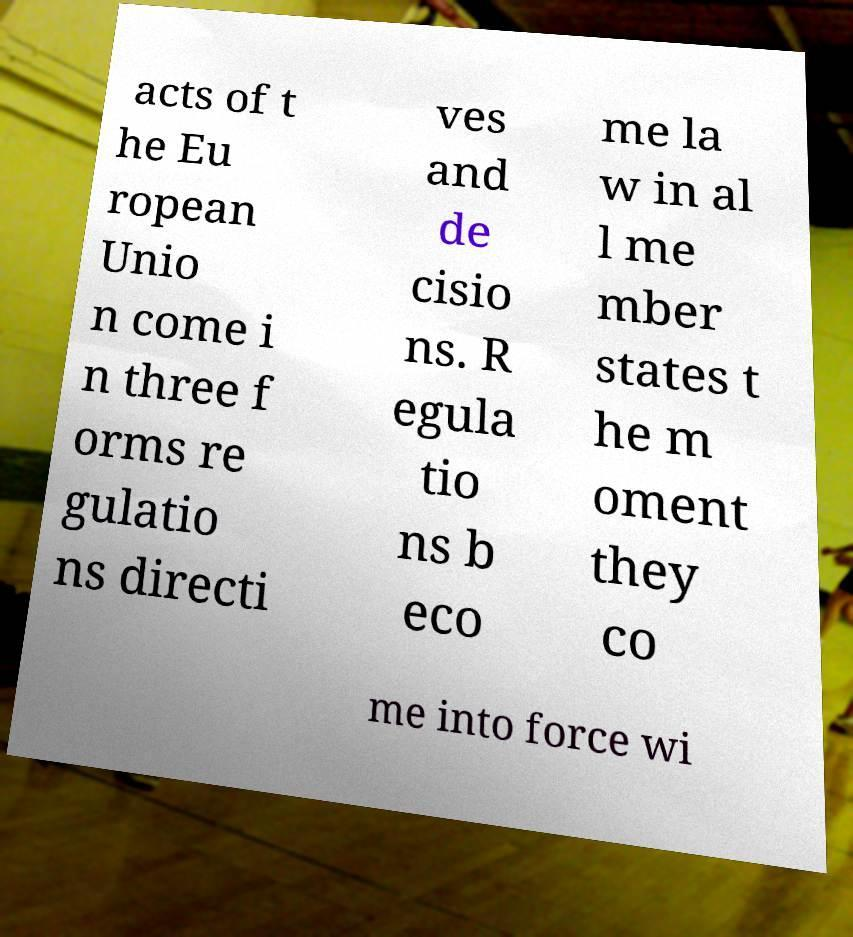For documentation purposes, I need the text within this image transcribed. Could you provide that? acts of t he Eu ropean Unio n come i n three f orms re gulatio ns directi ves and de cisio ns. R egula tio ns b eco me la w in al l me mber states t he m oment they co me into force wi 